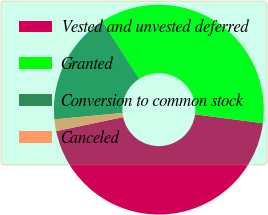<chart> <loc_0><loc_0><loc_500><loc_500><pie_chart><fcel>Vested and unvested deferred<fcel>Granted<fcel>Conversion to common stock<fcel>Canceled<nl><fcel>44.64%<fcel>36.13%<fcel>17.42%<fcel>1.81%<nl></chart> 